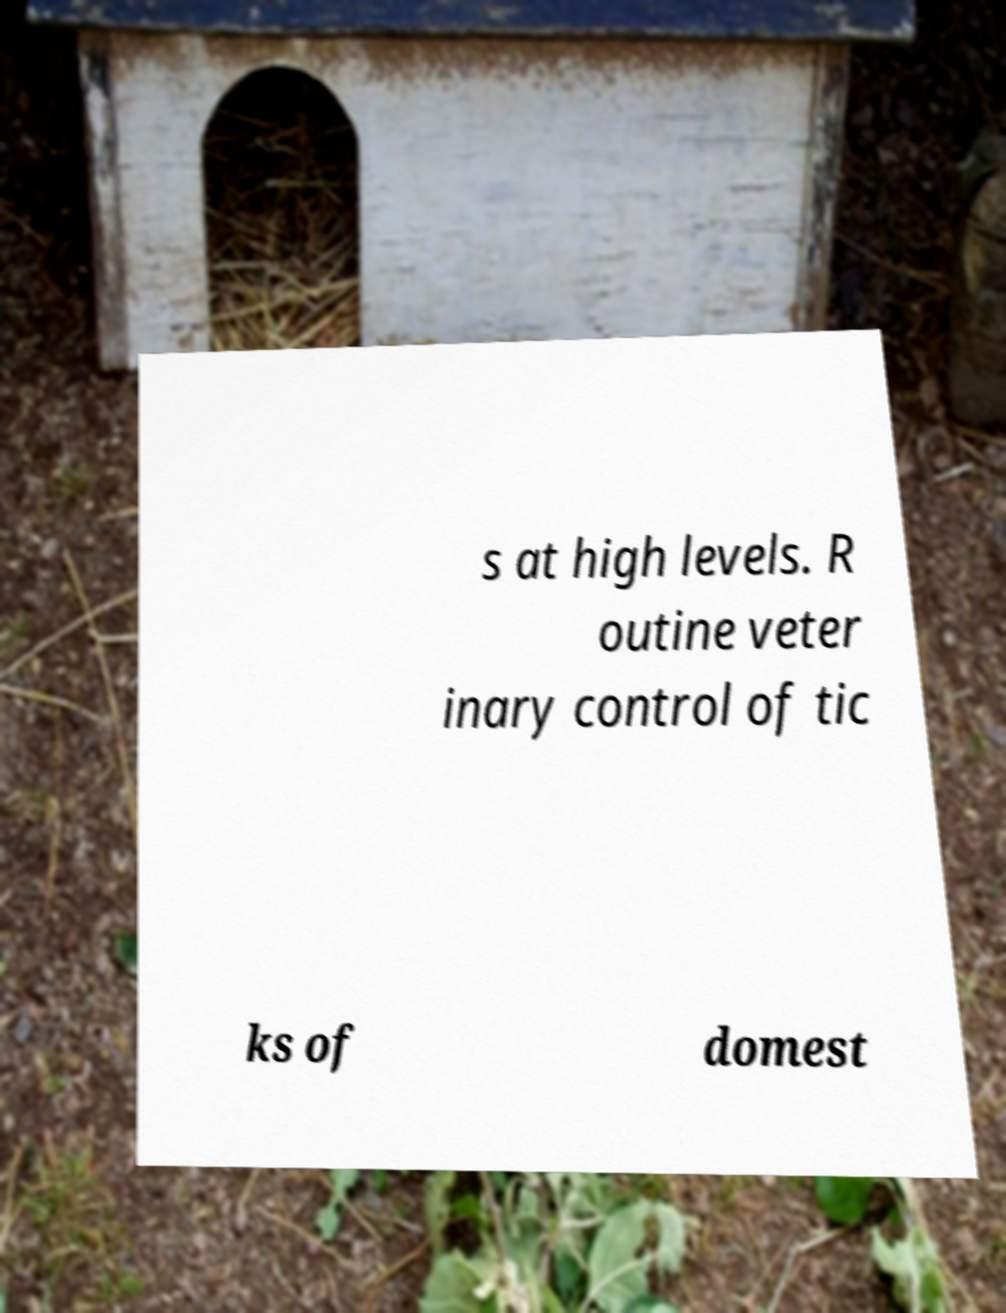For documentation purposes, I need the text within this image transcribed. Could you provide that? s at high levels. R outine veter inary control of tic ks of domest 